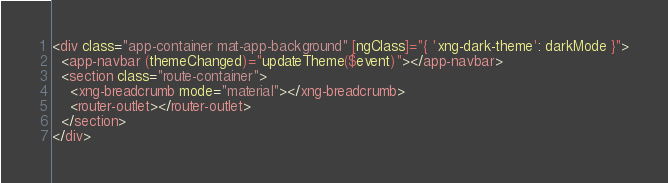<code> <loc_0><loc_0><loc_500><loc_500><_HTML_><div class="app-container mat-app-background" [ngClass]="{ 'xng-dark-theme': darkMode }">
  <app-navbar (themeChanged)="updateTheme($event)"></app-navbar>
  <section class="route-container">
    <xng-breadcrumb mode="material"></xng-breadcrumb>
    <router-outlet></router-outlet>
  </section>
</div>
</code> 